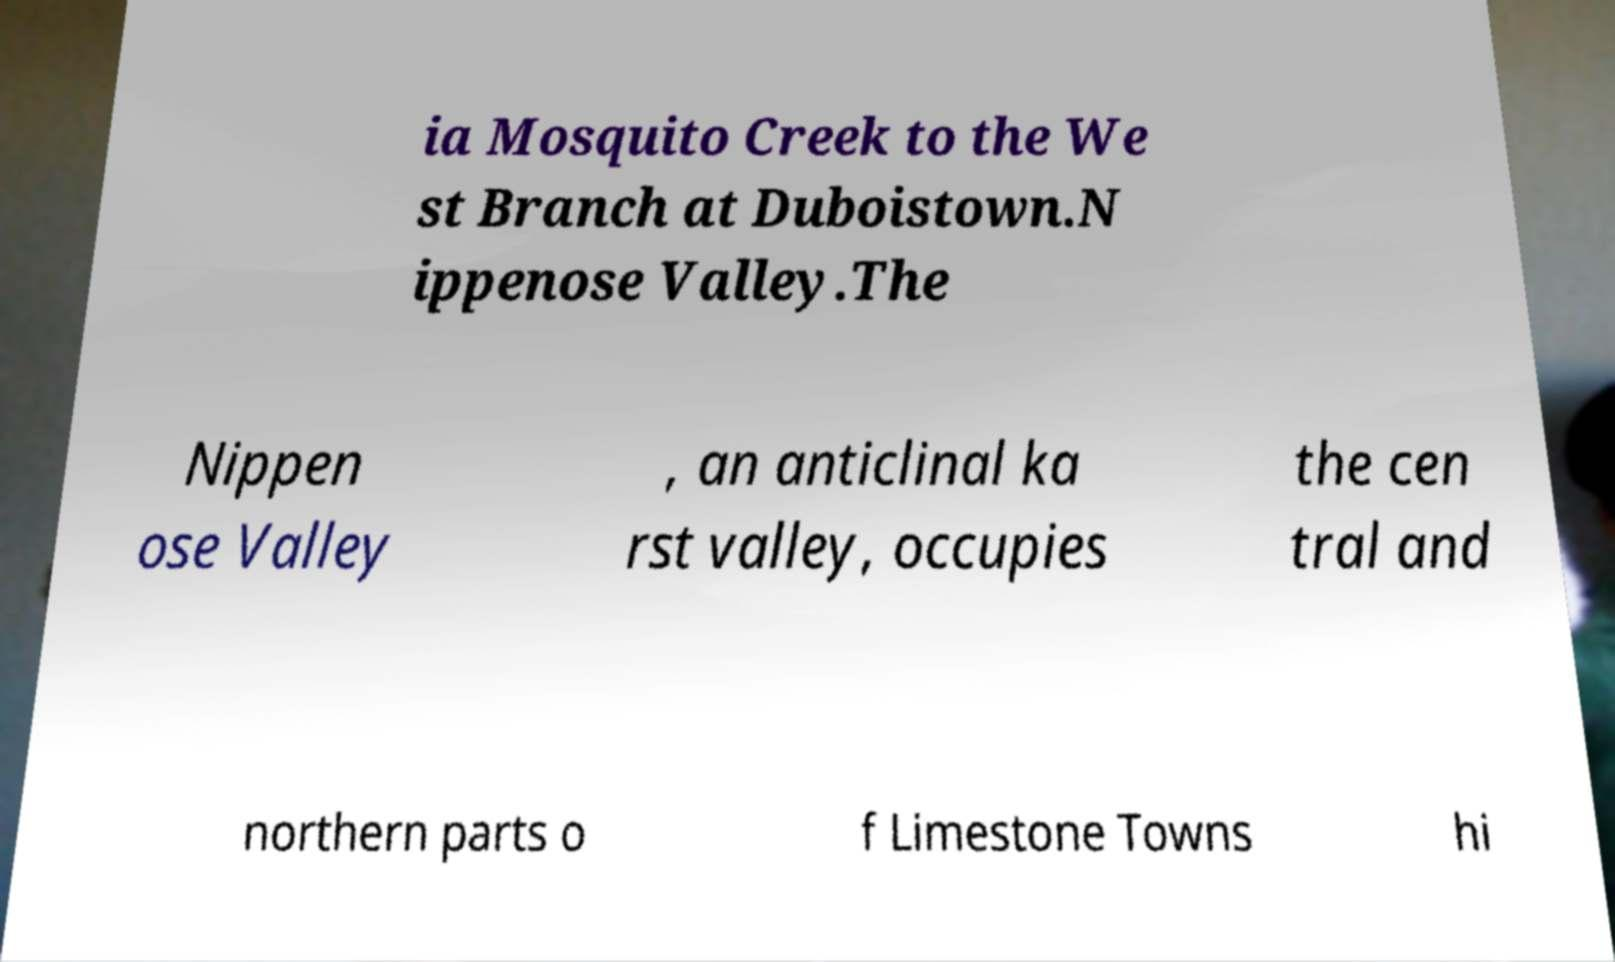What messages or text are displayed in this image? I need them in a readable, typed format. ia Mosquito Creek to the We st Branch at Duboistown.N ippenose Valley.The Nippen ose Valley , an anticlinal ka rst valley, occupies the cen tral and northern parts o f Limestone Towns hi 